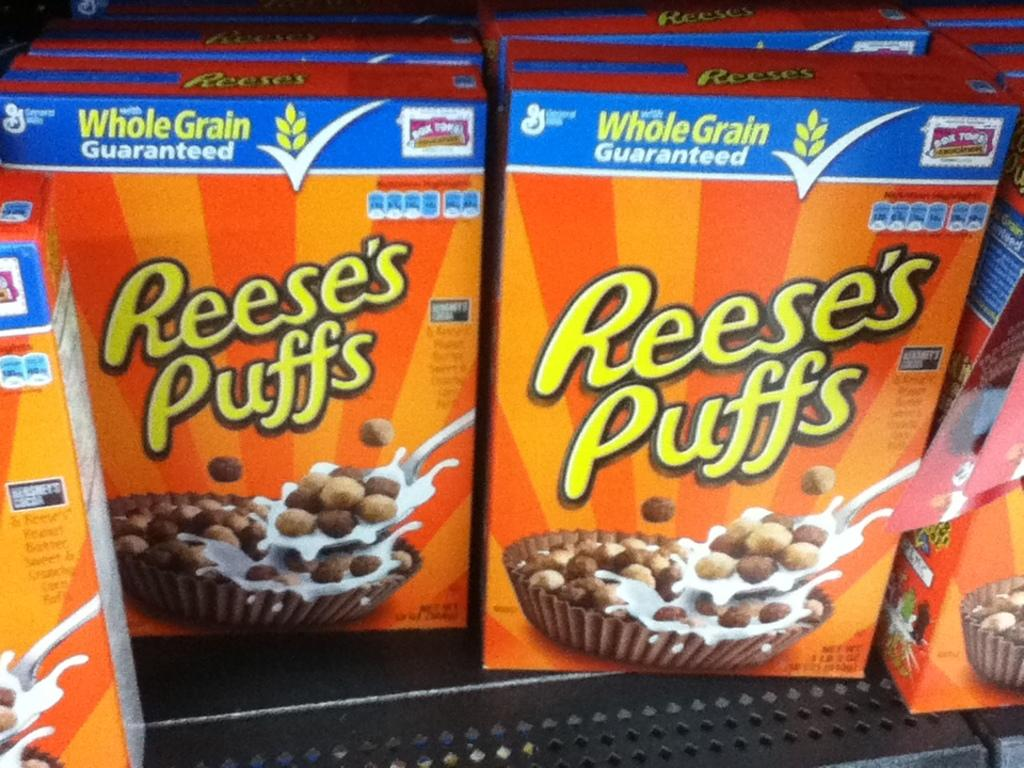What type of food items are featured in the image? There are whole grain boxes in the image. How are the whole grain boxes arranged or positioned in the image? The whole grain boxes are placed on the surface of a rack. What type of authority is depicted in the image? There is no authority figure present in the image; it features whole grain boxes placed on a rack. What type of brick is visible in the image? There is no brick present in the image. 